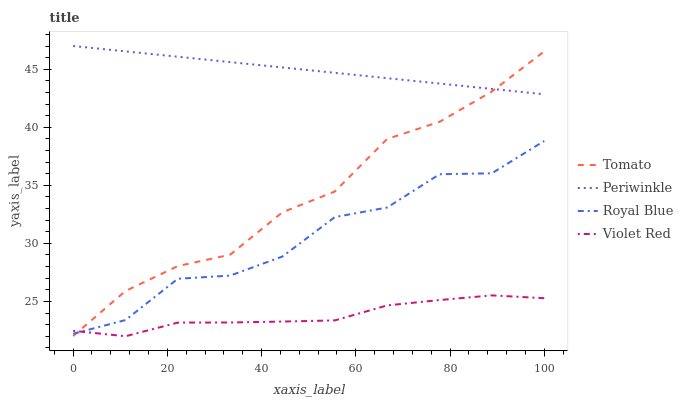Does Violet Red have the minimum area under the curve?
Answer yes or no. Yes. Does Royal Blue have the minimum area under the curve?
Answer yes or no. No. Does Royal Blue have the maximum area under the curve?
Answer yes or no. No. Is Periwinkle the smoothest?
Answer yes or no. Yes. Is Royal Blue the roughest?
Answer yes or no. Yes. Is Violet Red the smoothest?
Answer yes or no. No. Is Violet Red the roughest?
Answer yes or no. No. Does Royal Blue have the lowest value?
Answer yes or no. No. Does Royal Blue have the highest value?
Answer yes or no. No. Is Violet Red less than Periwinkle?
Answer yes or no. Yes. Is Periwinkle greater than Violet Red?
Answer yes or no. Yes. Does Violet Red intersect Periwinkle?
Answer yes or no. No. 